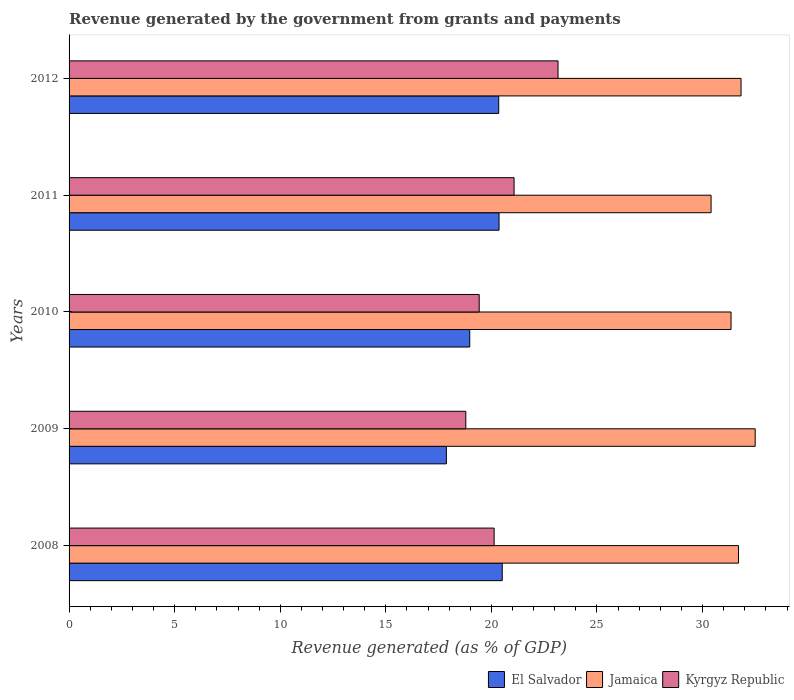How many different coloured bars are there?
Offer a terse response. 3. Are the number of bars per tick equal to the number of legend labels?
Provide a short and direct response. Yes. What is the label of the 1st group of bars from the top?
Give a very brief answer. 2012. What is the revenue generated by the government in Jamaica in 2008?
Your answer should be very brief. 31.7. Across all years, what is the maximum revenue generated by the government in Kyrgyz Republic?
Your response must be concise. 23.16. Across all years, what is the minimum revenue generated by the government in El Salvador?
Provide a short and direct response. 17.87. In which year was the revenue generated by the government in El Salvador minimum?
Your answer should be compact. 2009. What is the total revenue generated by the government in Kyrgyz Republic in the graph?
Provide a short and direct response. 102.57. What is the difference between the revenue generated by the government in Jamaica in 2010 and that in 2012?
Make the answer very short. -0.47. What is the difference between the revenue generated by the government in Jamaica in 2010 and the revenue generated by the government in El Salvador in 2008?
Your answer should be very brief. 10.84. What is the average revenue generated by the government in Jamaica per year?
Provide a short and direct response. 31.55. In the year 2012, what is the difference between the revenue generated by the government in Kyrgyz Republic and revenue generated by the government in El Salvador?
Ensure brevity in your answer.  2.81. What is the ratio of the revenue generated by the government in Jamaica in 2009 to that in 2012?
Your answer should be compact. 1.02. Is the revenue generated by the government in Jamaica in 2008 less than that in 2011?
Provide a short and direct response. No. What is the difference between the highest and the second highest revenue generated by the government in El Salvador?
Keep it short and to the point. 0.15. What is the difference between the highest and the lowest revenue generated by the government in Kyrgyz Republic?
Provide a succinct answer. 4.37. What does the 3rd bar from the top in 2011 represents?
Make the answer very short. El Salvador. What does the 2nd bar from the bottom in 2011 represents?
Make the answer very short. Jamaica. Is it the case that in every year, the sum of the revenue generated by the government in Jamaica and revenue generated by the government in Kyrgyz Republic is greater than the revenue generated by the government in El Salvador?
Your answer should be very brief. Yes. How many years are there in the graph?
Make the answer very short. 5. What is the difference between two consecutive major ticks on the X-axis?
Offer a terse response. 5. Are the values on the major ticks of X-axis written in scientific E-notation?
Keep it short and to the point. No. Does the graph contain any zero values?
Give a very brief answer. No. Does the graph contain grids?
Provide a succinct answer. No. Where does the legend appear in the graph?
Your answer should be very brief. Bottom right. How are the legend labels stacked?
Make the answer very short. Horizontal. What is the title of the graph?
Offer a terse response. Revenue generated by the government from grants and payments. What is the label or title of the X-axis?
Ensure brevity in your answer.  Revenue generated (as % of GDP). What is the label or title of the Y-axis?
Offer a very short reply. Years. What is the Revenue generated (as % of GDP) in El Salvador in 2008?
Your answer should be compact. 20.51. What is the Revenue generated (as % of GDP) of Jamaica in 2008?
Offer a very short reply. 31.7. What is the Revenue generated (as % of GDP) in Kyrgyz Republic in 2008?
Your answer should be very brief. 20.13. What is the Revenue generated (as % of GDP) in El Salvador in 2009?
Offer a terse response. 17.87. What is the Revenue generated (as % of GDP) in Jamaica in 2009?
Keep it short and to the point. 32.49. What is the Revenue generated (as % of GDP) of Kyrgyz Republic in 2009?
Keep it short and to the point. 18.79. What is the Revenue generated (as % of GDP) of El Salvador in 2010?
Your answer should be very brief. 18.97. What is the Revenue generated (as % of GDP) of Jamaica in 2010?
Make the answer very short. 31.35. What is the Revenue generated (as % of GDP) of Kyrgyz Republic in 2010?
Ensure brevity in your answer.  19.42. What is the Revenue generated (as % of GDP) of El Salvador in 2011?
Make the answer very short. 20.36. What is the Revenue generated (as % of GDP) in Jamaica in 2011?
Your response must be concise. 30.4. What is the Revenue generated (as % of GDP) of Kyrgyz Republic in 2011?
Provide a short and direct response. 21.07. What is the Revenue generated (as % of GDP) of El Salvador in 2012?
Offer a very short reply. 20.35. What is the Revenue generated (as % of GDP) in Jamaica in 2012?
Offer a terse response. 31.82. What is the Revenue generated (as % of GDP) of Kyrgyz Republic in 2012?
Provide a short and direct response. 23.16. Across all years, what is the maximum Revenue generated (as % of GDP) in El Salvador?
Give a very brief answer. 20.51. Across all years, what is the maximum Revenue generated (as % of GDP) of Jamaica?
Give a very brief answer. 32.49. Across all years, what is the maximum Revenue generated (as % of GDP) of Kyrgyz Republic?
Your response must be concise. 23.16. Across all years, what is the minimum Revenue generated (as % of GDP) of El Salvador?
Give a very brief answer. 17.87. Across all years, what is the minimum Revenue generated (as % of GDP) of Jamaica?
Your response must be concise. 30.4. Across all years, what is the minimum Revenue generated (as % of GDP) of Kyrgyz Republic?
Offer a terse response. 18.79. What is the total Revenue generated (as % of GDP) of El Salvador in the graph?
Give a very brief answer. 98.06. What is the total Revenue generated (as % of GDP) in Jamaica in the graph?
Keep it short and to the point. 157.77. What is the total Revenue generated (as % of GDP) of Kyrgyz Republic in the graph?
Give a very brief answer. 102.57. What is the difference between the Revenue generated (as % of GDP) in El Salvador in 2008 and that in 2009?
Provide a short and direct response. 2.64. What is the difference between the Revenue generated (as % of GDP) of Jamaica in 2008 and that in 2009?
Your answer should be compact. -0.79. What is the difference between the Revenue generated (as % of GDP) in Kyrgyz Republic in 2008 and that in 2009?
Give a very brief answer. 1.34. What is the difference between the Revenue generated (as % of GDP) of El Salvador in 2008 and that in 2010?
Offer a very short reply. 1.54. What is the difference between the Revenue generated (as % of GDP) of Jamaica in 2008 and that in 2010?
Keep it short and to the point. 0.35. What is the difference between the Revenue generated (as % of GDP) in Kyrgyz Republic in 2008 and that in 2010?
Your answer should be compact. 0.71. What is the difference between the Revenue generated (as % of GDP) of El Salvador in 2008 and that in 2011?
Offer a terse response. 0.15. What is the difference between the Revenue generated (as % of GDP) of Jamaica in 2008 and that in 2011?
Keep it short and to the point. 1.3. What is the difference between the Revenue generated (as % of GDP) in Kyrgyz Republic in 2008 and that in 2011?
Your response must be concise. -0.94. What is the difference between the Revenue generated (as % of GDP) of El Salvador in 2008 and that in 2012?
Offer a terse response. 0.17. What is the difference between the Revenue generated (as % of GDP) in Jamaica in 2008 and that in 2012?
Offer a terse response. -0.12. What is the difference between the Revenue generated (as % of GDP) of Kyrgyz Republic in 2008 and that in 2012?
Provide a short and direct response. -3.03. What is the difference between the Revenue generated (as % of GDP) in El Salvador in 2009 and that in 2010?
Provide a succinct answer. -1.11. What is the difference between the Revenue generated (as % of GDP) of Jamaica in 2009 and that in 2010?
Keep it short and to the point. 1.14. What is the difference between the Revenue generated (as % of GDP) of Kyrgyz Republic in 2009 and that in 2010?
Offer a terse response. -0.63. What is the difference between the Revenue generated (as % of GDP) in El Salvador in 2009 and that in 2011?
Your answer should be very brief. -2.49. What is the difference between the Revenue generated (as % of GDP) in Jamaica in 2009 and that in 2011?
Ensure brevity in your answer.  2.09. What is the difference between the Revenue generated (as % of GDP) of Kyrgyz Republic in 2009 and that in 2011?
Provide a succinct answer. -2.29. What is the difference between the Revenue generated (as % of GDP) of El Salvador in 2009 and that in 2012?
Make the answer very short. -2.48. What is the difference between the Revenue generated (as % of GDP) of Jamaica in 2009 and that in 2012?
Your response must be concise. 0.67. What is the difference between the Revenue generated (as % of GDP) of Kyrgyz Republic in 2009 and that in 2012?
Your answer should be very brief. -4.37. What is the difference between the Revenue generated (as % of GDP) of El Salvador in 2010 and that in 2011?
Your answer should be very brief. -1.39. What is the difference between the Revenue generated (as % of GDP) of Jamaica in 2010 and that in 2011?
Your answer should be compact. 0.95. What is the difference between the Revenue generated (as % of GDP) in Kyrgyz Republic in 2010 and that in 2011?
Your response must be concise. -1.65. What is the difference between the Revenue generated (as % of GDP) in El Salvador in 2010 and that in 2012?
Give a very brief answer. -1.37. What is the difference between the Revenue generated (as % of GDP) in Jamaica in 2010 and that in 2012?
Offer a very short reply. -0.47. What is the difference between the Revenue generated (as % of GDP) of Kyrgyz Republic in 2010 and that in 2012?
Keep it short and to the point. -3.73. What is the difference between the Revenue generated (as % of GDP) of El Salvador in 2011 and that in 2012?
Your response must be concise. 0.02. What is the difference between the Revenue generated (as % of GDP) in Jamaica in 2011 and that in 2012?
Ensure brevity in your answer.  -1.42. What is the difference between the Revenue generated (as % of GDP) of Kyrgyz Republic in 2011 and that in 2012?
Your response must be concise. -2.08. What is the difference between the Revenue generated (as % of GDP) in El Salvador in 2008 and the Revenue generated (as % of GDP) in Jamaica in 2009?
Provide a succinct answer. -11.98. What is the difference between the Revenue generated (as % of GDP) of El Salvador in 2008 and the Revenue generated (as % of GDP) of Kyrgyz Republic in 2009?
Make the answer very short. 1.73. What is the difference between the Revenue generated (as % of GDP) in Jamaica in 2008 and the Revenue generated (as % of GDP) in Kyrgyz Republic in 2009?
Your response must be concise. 12.91. What is the difference between the Revenue generated (as % of GDP) in El Salvador in 2008 and the Revenue generated (as % of GDP) in Jamaica in 2010?
Your answer should be compact. -10.84. What is the difference between the Revenue generated (as % of GDP) of El Salvador in 2008 and the Revenue generated (as % of GDP) of Kyrgyz Republic in 2010?
Provide a succinct answer. 1.09. What is the difference between the Revenue generated (as % of GDP) in Jamaica in 2008 and the Revenue generated (as % of GDP) in Kyrgyz Republic in 2010?
Your answer should be very brief. 12.28. What is the difference between the Revenue generated (as % of GDP) of El Salvador in 2008 and the Revenue generated (as % of GDP) of Jamaica in 2011?
Provide a short and direct response. -9.89. What is the difference between the Revenue generated (as % of GDP) of El Salvador in 2008 and the Revenue generated (as % of GDP) of Kyrgyz Republic in 2011?
Ensure brevity in your answer.  -0.56. What is the difference between the Revenue generated (as % of GDP) in Jamaica in 2008 and the Revenue generated (as % of GDP) in Kyrgyz Republic in 2011?
Your answer should be compact. 10.63. What is the difference between the Revenue generated (as % of GDP) of El Salvador in 2008 and the Revenue generated (as % of GDP) of Jamaica in 2012?
Offer a very short reply. -11.31. What is the difference between the Revenue generated (as % of GDP) in El Salvador in 2008 and the Revenue generated (as % of GDP) in Kyrgyz Republic in 2012?
Keep it short and to the point. -2.64. What is the difference between the Revenue generated (as % of GDP) of Jamaica in 2008 and the Revenue generated (as % of GDP) of Kyrgyz Republic in 2012?
Your response must be concise. 8.55. What is the difference between the Revenue generated (as % of GDP) in El Salvador in 2009 and the Revenue generated (as % of GDP) in Jamaica in 2010?
Your answer should be very brief. -13.48. What is the difference between the Revenue generated (as % of GDP) of El Salvador in 2009 and the Revenue generated (as % of GDP) of Kyrgyz Republic in 2010?
Your answer should be compact. -1.55. What is the difference between the Revenue generated (as % of GDP) in Jamaica in 2009 and the Revenue generated (as % of GDP) in Kyrgyz Republic in 2010?
Provide a short and direct response. 13.07. What is the difference between the Revenue generated (as % of GDP) in El Salvador in 2009 and the Revenue generated (as % of GDP) in Jamaica in 2011?
Provide a succinct answer. -12.54. What is the difference between the Revenue generated (as % of GDP) in El Salvador in 2009 and the Revenue generated (as % of GDP) in Kyrgyz Republic in 2011?
Provide a short and direct response. -3.21. What is the difference between the Revenue generated (as % of GDP) of Jamaica in 2009 and the Revenue generated (as % of GDP) of Kyrgyz Republic in 2011?
Give a very brief answer. 11.42. What is the difference between the Revenue generated (as % of GDP) in El Salvador in 2009 and the Revenue generated (as % of GDP) in Jamaica in 2012?
Offer a terse response. -13.95. What is the difference between the Revenue generated (as % of GDP) of El Salvador in 2009 and the Revenue generated (as % of GDP) of Kyrgyz Republic in 2012?
Provide a succinct answer. -5.29. What is the difference between the Revenue generated (as % of GDP) of Jamaica in 2009 and the Revenue generated (as % of GDP) of Kyrgyz Republic in 2012?
Give a very brief answer. 9.34. What is the difference between the Revenue generated (as % of GDP) in El Salvador in 2010 and the Revenue generated (as % of GDP) in Jamaica in 2011?
Your answer should be compact. -11.43. What is the difference between the Revenue generated (as % of GDP) in El Salvador in 2010 and the Revenue generated (as % of GDP) in Kyrgyz Republic in 2011?
Your answer should be compact. -2.1. What is the difference between the Revenue generated (as % of GDP) in Jamaica in 2010 and the Revenue generated (as % of GDP) in Kyrgyz Republic in 2011?
Keep it short and to the point. 10.27. What is the difference between the Revenue generated (as % of GDP) in El Salvador in 2010 and the Revenue generated (as % of GDP) in Jamaica in 2012?
Your answer should be compact. -12.85. What is the difference between the Revenue generated (as % of GDP) of El Salvador in 2010 and the Revenue generated (as % of GDP) of Kyrgyz Republic in 2012?
Your response must be concise. -4.18. What is the difference between the Revenue generated (as % of GDP) of Jamaica in 2010 and the Revenue generated (as % of GDP) of Kyrgyz Republic in 2012?
Offer a terse response. 8.19. What is the difference between the Revenue generated (as % of GDP) of El Salvador in 2011 and the Revenue generated (as % of GDP) of Jamaica in 2012?
Give a very brief answer. -11.46. What is the difference between the Revenue generated (as % of GDP) in El Salvador in 2011 and the Revenue generated (as % of GDP) in Kyrgyz Republic in 2012?
Ensure brevity in your answer.  -2.79. What is the difference between the Revenue generated (as % of GDP) in Jamaica in 2011 and the Revenue generated (as % of GDP) in Kyrgyz Republic in 2012?
Your answer should be very brief. 7.25. What is the average Revenue generated (as % of GDP) of El Salvador per year?
Make the answer very short. 19.61. What is the average Revenue generated (as % of GDP) in Jamaica per year?
Give a very brief answer. 31.55. What is the average Revenue generated (as % of GDP) of Kyrgyz Republic per year?
Provide a short and direct response. 20.51. In the year 2008, what is the difference between the Revenue generated (as % of GDP) of El Salvador and Revenue generated (as % of GDP) of Jamaica?
Make the answer very short. -11.19. In the year 2008, what is the difference between the Revenue generated (as % of GDP) in El Salvador and Revenue generated (as % of GDP) in Kyrgyz Republic?
Provide a succinct answer. 0.38. In the year 2008, what is the difference between the Revenue generated (as % of GDP) in Jamaica and Revenue generated (as % of GDP) in Kyrgyz Republic?
Offer a very short reply. 11.57. In the year 2009, what is the difference between the Revenue generated (as % of GDP) of El Salvador and Revenue generated (as % of GDP) of Jamaica?
Your answer should be very brief. -14.62. In the year 2009, what is the difference between the Revenue generated (as % of GDP) of El Salvador and Revenue generated (as % of GDP) of Kyrgyz Republic?
Ensure brevity in your answer.  -0.92. In the year 2009, what is the difference between the Revenue generated (as % of GDP) of Jamaica and Revenue generated (as % of GDP) of Kyrgyz Republic?
Your answer should be very brief. 13.7. In the year 2010, what is the difference between the Revenue generated (as % of GDP) in El Salvador and Revenue generated (as % of GDP) in Jamaica?
Ensure brevity in your answer.  -12.37. In the year 2010, what is the difference between the Revenue generated (as % of GDP) in El Salvador and Revenue generated (as % of GDP) in Kyrgyz Republic?
Give a very brief answer. -0.45. In the year 2010, what is the difference between the Revenue generated (as % of GDP) of Jamaica and Revenue generated (as % of GDP) of Kyrgyz Republic?
Make the answer very short. 11.93. In the year 2011, what is the difference between the Revenue generated (as % of GDP) of El Salvador and Revenue generated (as % of GDP) of Jamaica?
Your answer should be compact. -10.04. In the year 2011, what is the difference between the Revenue generated (as % of GDP) in El Salvador and Revenue generated (as % of GDP) in Kyrgyz Republic?
Give a very brief answer. -0.71. In the year 2011, what is the difference between the Revenue generated (as % of GDP) in Jamaica and Revenue generated (as % of GDP) in Kyrgyz Republic?
Offer a terse response. 9.33. In the year 2012, what is the difference between the Revenue generated (as % of GDP) of El Salvador and Revenue generated (as % of GDP) of Jamaica?
Your response must be concise. -11.48. In the year 2012, what is the difference between the Revenue generated (as % of GDP) in El Salvador and Revenue generated (as % of GDP) in Kyrgyz Republic?
Your answer should be very brief. -2.81. In the year 2012, what is the difference between the Revenue generated (as % of GDP) of Jamaica and Revenue generated (as % of GDP) of Kyrgyz Republic?
Ensure brevity in your answer.  8.67. What is the ratio of the Revenue generated (as % of GDP) of El Salvador in 2008 to that in 2009?
Make the answer very short. 1.15. What is the ratio of the Revenue generated (as % of GDP) in Jamaica in 2008 to that in 2009?
Give a very brief answer. 0.98. What is the ratio of the Revenue generated (as % of GDP) in Kyrgyz Republic in 2008 to that in 2009?
Ensure brevity in your answer.  1.07. What is the ratio of the Revenue generated (as % of GDP) in El Salvador in 2008 to that in 2010?
Your response must be concise. 1.08. What is the ratio of the Revenue generated (as % of GDP) of Jamaica in 2008 to that in 2010?
Your response must be concise. 1.01. What is the ratio of the Revenue generated (as % of GDP) in Kyrgyz Republic in 2008 to that in 2010?
Offer a terse response. 1.04. What is the ratio of the Revenue generated (as % of GDP) in El Salvador in 2008 to that in 2011?
Your answer should be very brief. 1.01. What is the ratio of the Revenue generated (as % of GDP) of Jamaica in 2008 to that in 2011?
Your answer should be compact. 1.04. What is the ratio of the Revenue generated (as % of GDP) of Kyrgyz Republic in 2008 to that in 2011?
Offer a terse response. 0.96. What is the ratio of the Revenue generated (as % of GDP) of El Salvador in 2008 to that in 2012?
Offer a terse response. 1.01. What is the ratio of the Revenue generated (as % of GDP) of Kyrgyz Republic in 2008 to that in 2012?
Your response must be concise. 0.87. What is the ratio of the Revenue generated (as % of GDP) in El Salvador in 2009 to that in 2010?
Offer a terse response. 0.94. What is the ratio of the Revenue generated (as % of GDP) in Jamaica in 2009 to that in 2010?
Give a very brief answer. 1.04. What is the ratio of the Revenue generated (as % of GDP) in Kyrgyz Republic in 2009 to that in 2010?
Offer a very short reply. 0.97. What is the ratio of the Revenue generated (as % of GDP) in El Salvador in 2009 to that in 2011?
Offer a very short reply. 0.88. What is the ratio of the Revenue generated (as % of GDP) in Jamaica in 2009 to that in 2011?
Give a very brief answer. 1.07. What is the ratio of the Revenue generated (as % of GDP) in Kyrgyz Republic in 2009 to that in 2011?
Provide a short and direct response. 0.89. What is the ratio of the Revenue generated (as % of GDP) in El Salvador in 2009 to that in 2012?
Provide a short and direct response. 0.88. What is the ratio of the Revenue generated (as % of GDP) in Jamaica in 2009 to that in 2012?
Your response must be concise. 1.02. What is the ratio of the Revenue generated (as % of GDP) of Kyrgyz Republic in 2009 to that in 2012?
Your answer should be compact. 0.81. What is the ratio of the Revenue generated (as % of GDP) in El Salvador in 2010 to that in 2011?
Make the answer very short. 0.93. What is the ratio of the Revenue generated (as % of GDP) of Jamaica in 2010 to that in 2011?
Provide a short and direct response. 1.03. What is the ratio of the Revenue generated (as % of GDP) in Kyrgyz Republic in 2010 to that in 2011?
Give a very brief answer. 0.92. What is the ratio of the Revenue generated (as % of GDP) in El Salvador in 2010 to that in 2012?
Provide a succinct answer. 0.93. What is the ratio of the Revenue generated (as % of GDP) of Jamaica in 2010 to that in 2012?
Provide a succinct answer. 0.99. What is the ratio of the Revenue generated (as % of GDP) in Kyrgyz Republic in 2010 to that in 2012?
Your response must be concise. 0.84. What is the ratio of the Revenue generated (as % of GDP) of El Salvador in 2011 to that in 2012?
Offer a terse response. 1. What is the ratio of the Revenue generated (as % of GDP) of Jamaica in 2011 to that in 2012?
Give a very brief answer. 0.96. What is the ratio of the Revenue generated (as % of GDP) in Kyrgyz Republic in 2011 to that in 2012?
Provide a succinct answer. 0.91. What is the difference between the highest and the second highest Revenue generated (as % of GDP) of El Salvador?
Provide a short and direct response. 0.15. What is the difference between the highest and the second highest Revenue generated (as % of GDP) of Jamaica?
Provide a short and direct response. 0.67. What is the difference between the highest and the second highest Revenue generated (as % of GDP) of Kyrgyz Republic?
Provide a short and direct response. 2.08. What is the difference between the highest and the lowest Revenue generated (as % of GDP) of El Salvador?
Your answer should be compact. 2.64. What is the difference between the highest and the lowest Revenue generated (as % of GDP) of Jamaica?
Offer a terse response. 2.09. What is the difference between the highest and the lowest Revenue generated (as % of GDP) of Kyrgyz Republic?
Offer a terse response. 4.37. 